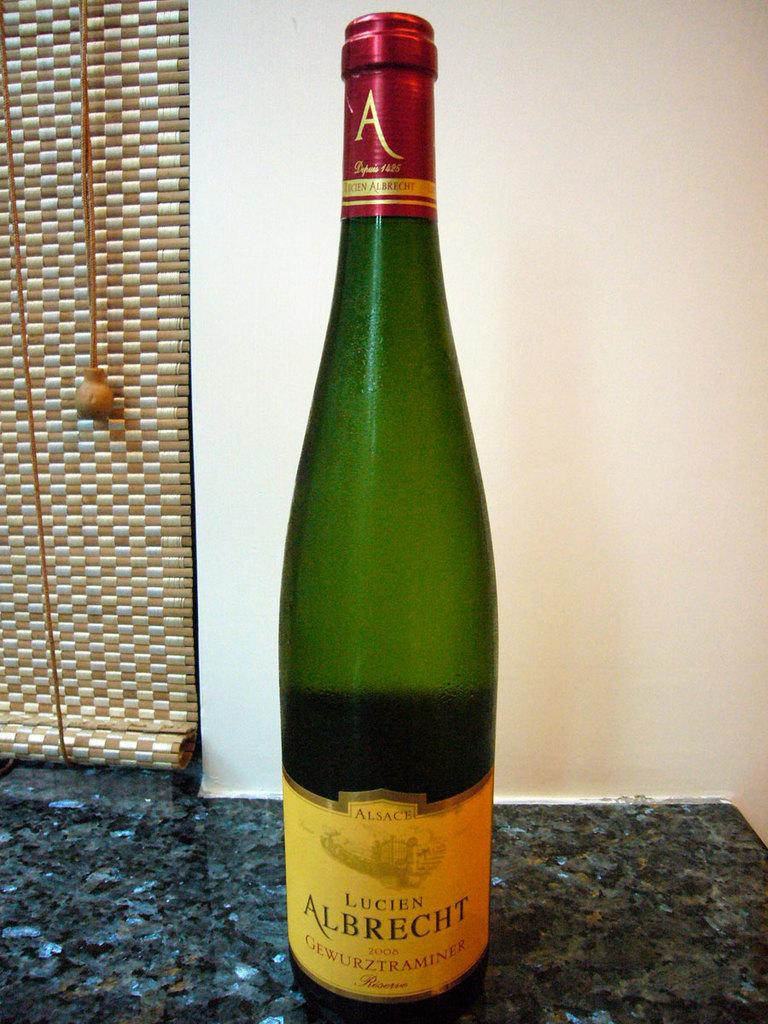What is the main subject of the image? The main subject of the image is a beverage. Where is the beverage located in the image? The beverage is placed on a counter table in the image. What can be seen in the background of the image? There is a curtain and a wall in the background of the image. What type of straw is used to roll the beverage in the image? There is no straw or rolling action present in the image; the beverage is simply placed on a counter table. 